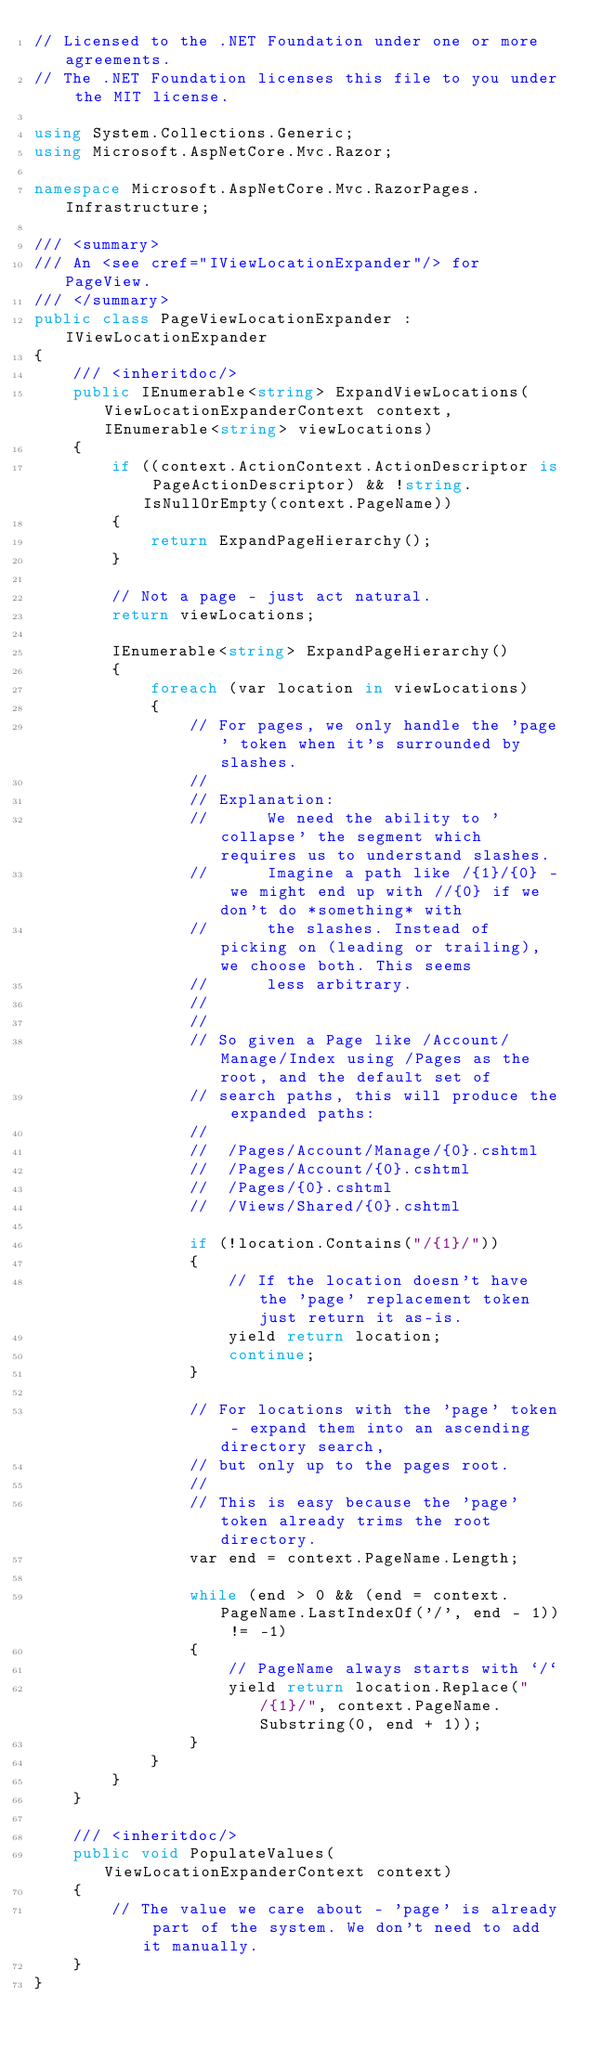Convert code to text. <code><loc_0><loc_0><loc_500><loc_500><_C#_>// Licensed to the .NET Foundation under one or more agreements.
// The .NET Foundation licenses this file to you under the MIT license.

using System.Collections.Generic;
using Microsoft.AspNetCore.Mvc.Razor;

namespace Microsoft.AspNetCore.Mvc.RazorPages.Infrastructure;

/// <summary>
/// An <see cref="IViewLocationExpander"/> for PageView.
/// </summary>
public class PageViewLocationExpander : IViewLocationExpander
{
    /// <inheritdoc/>
    public IEnumerable<string> ExpandViewLocations(ViewLocationExpanderContext context, IEnumerable<string> viewLocations)
    {
        if ((context.ActionContext.ActionDescriptor is PageActionDescriptor) && !string.IsNullOrEmpty(context.PageName))
        {
            return ExpandPageHierarchy();
        }

        // Not a page - just act natural.
        return viewLocations;

        IEnumerable<string> ExpandPageHierarchy()
        {
            foreach (var location in viewLocations)
            {
                // For pages, we only handle the 'page' token when it's surrounded by slashes.
                //
                // Explanation:
                //      We need the ability to 'collapse' the segment which requires us to understand slashes.
                //      Imagine a path like /{1}/{0} - we might end up with //{0} if we don't do *something* with
                //      the slashes. Instead of picking on (leading or trailing), we choose both. This seems
                //      less arbitrary.
                //
                //
                // So given a Page like /Account/Manage/Index using /Pages as the root, and the default set of
                // search paths, this will produce the expanded paths:
                //
                //  /Pages/Account/Manage/{0}.cshtml
                //  /Pages/Account/{0}.cshtml
                //  /Pages/{0}.cshtml
                //  /Views/Shared/{0}.cshtml

                if (!location.Contains("/{1}/"))
                {
                    // If the location doesn't have the 'page' replacement token just return it as-is.
                    yield return location;
                    continue;
                }

                // For locations with the 'page' token - expand them into an ascending directory search,
                // but only up to the pages root.
                //
                // This is easy because the 'page' token already trims the root directory.
                var end = context.PageName.Length;

                while (end > 0 && (end = context.PageName.LastIndexOf('/', end - 1)) != -1)
                {
                    // PageName always starts with `/`
                    yield return location.Replace("/{1}/", context.PageName.Substring(0, end + 1));
                }
            }
        }
    }

    /// <inheritdoc/>
    public void PopulateValues(ViewLocationExpanderContext context)
    {
        // The value we care about - 'page' is already part of the system. We don't need to add it manually.
    }
}
</code> 